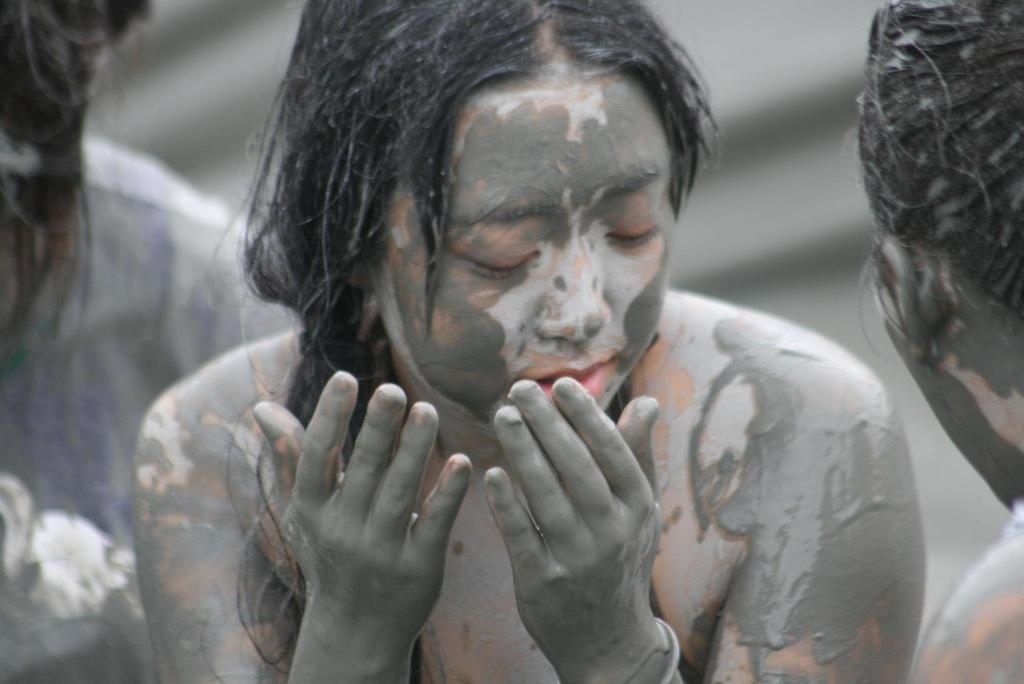Who or what is present in the image? There are people in the image. What is the condition of the people in the image? The people have mud on them. Can you describe the background of the image? The background of the image is blurred. What type of yarn is being used by the people in the image? There is no yarn present in the image; the people have mud on them. Can you tell me what request the people in the image are making? There is no indication of a request being made in the image; the people have mud on them and the background is blurred. 